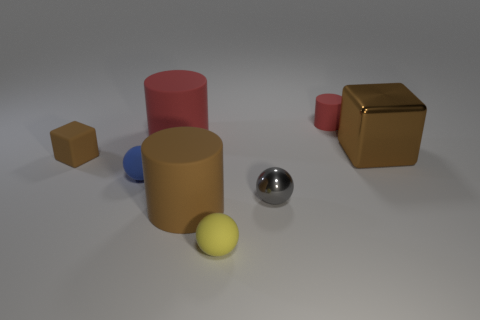There is a cube that is on the right side of the yellow rubber ball; is its size the same as the metallic sphere?
Make the answer very short. No. Is the color of the tiny metallic ball the same as the small cylinder?
Your response must be concise. No. What number of big blue shiny cubes are there?
Make the answer very short. 0. How many spheres are either metallic things or tiny purple things?
Give a very brief answer. 1. What number of big red things are right of the tiny brown matte object that is on the left side of the large red matte cylinder?
Your answer should be very brief. 1. Is the tiny gray object made of the same material as the small blue object?
Offer a very short reply. No. What is the size of the shiny object that is the same color as the matte cube?
Make the answer very short. Large. Are there any other small brown objects that have the same material as the tiny brown thing?
Offer a terse response. No. What is the color of the small matte sphere that is in front of the large matte cylinder in front of the brown block that is in front of the large brown metal block?
Your answer should be compact. Yellow. How many brown things are large spheres or big cubes?
Keep it short and to the point. 1. 